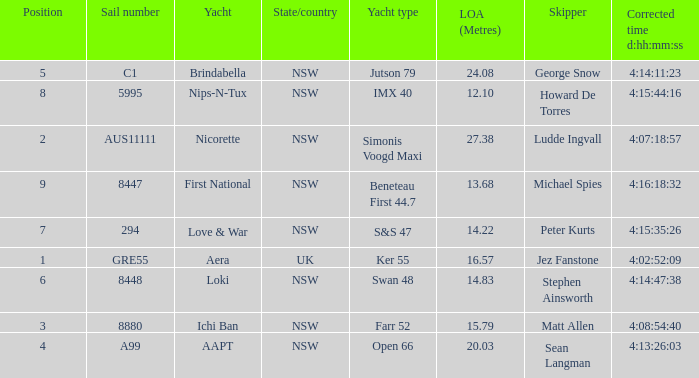What is the overall length of sail for the boat with a correct time of 4:15:35:26? 14.22. 